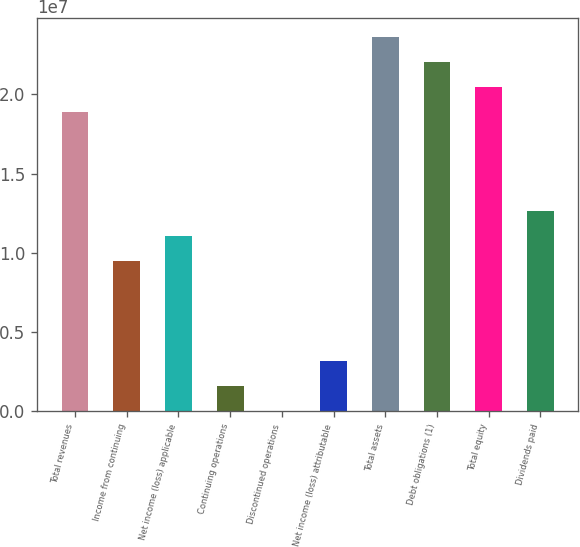Convert chart. <chart><loc_0><loc_0><loc_500><loc_500><bar_chart><fcel>Total revenues<fcel>Income from continuing<fcel>Net income (loss) applicable<fcel>Continuing operations<fcel>Discontinued operations<fcel>Net income (loss) attributable<fcel>Total assets<fcel>Debt obligations (1)<fcel>Total equity<fcel>Dividends paid<nl><fcel>1.89111e+07<fcel>9.45556e+06<fcel>1.10315e+07<fcel>1.57593e+06<fcel>0.57<fcel>3.15185e+06<fcel>2.36389e+07<fcel>2.2063e+07<fcel>2.0487e+07<fcel>1.26074e+07<nl></chart> 